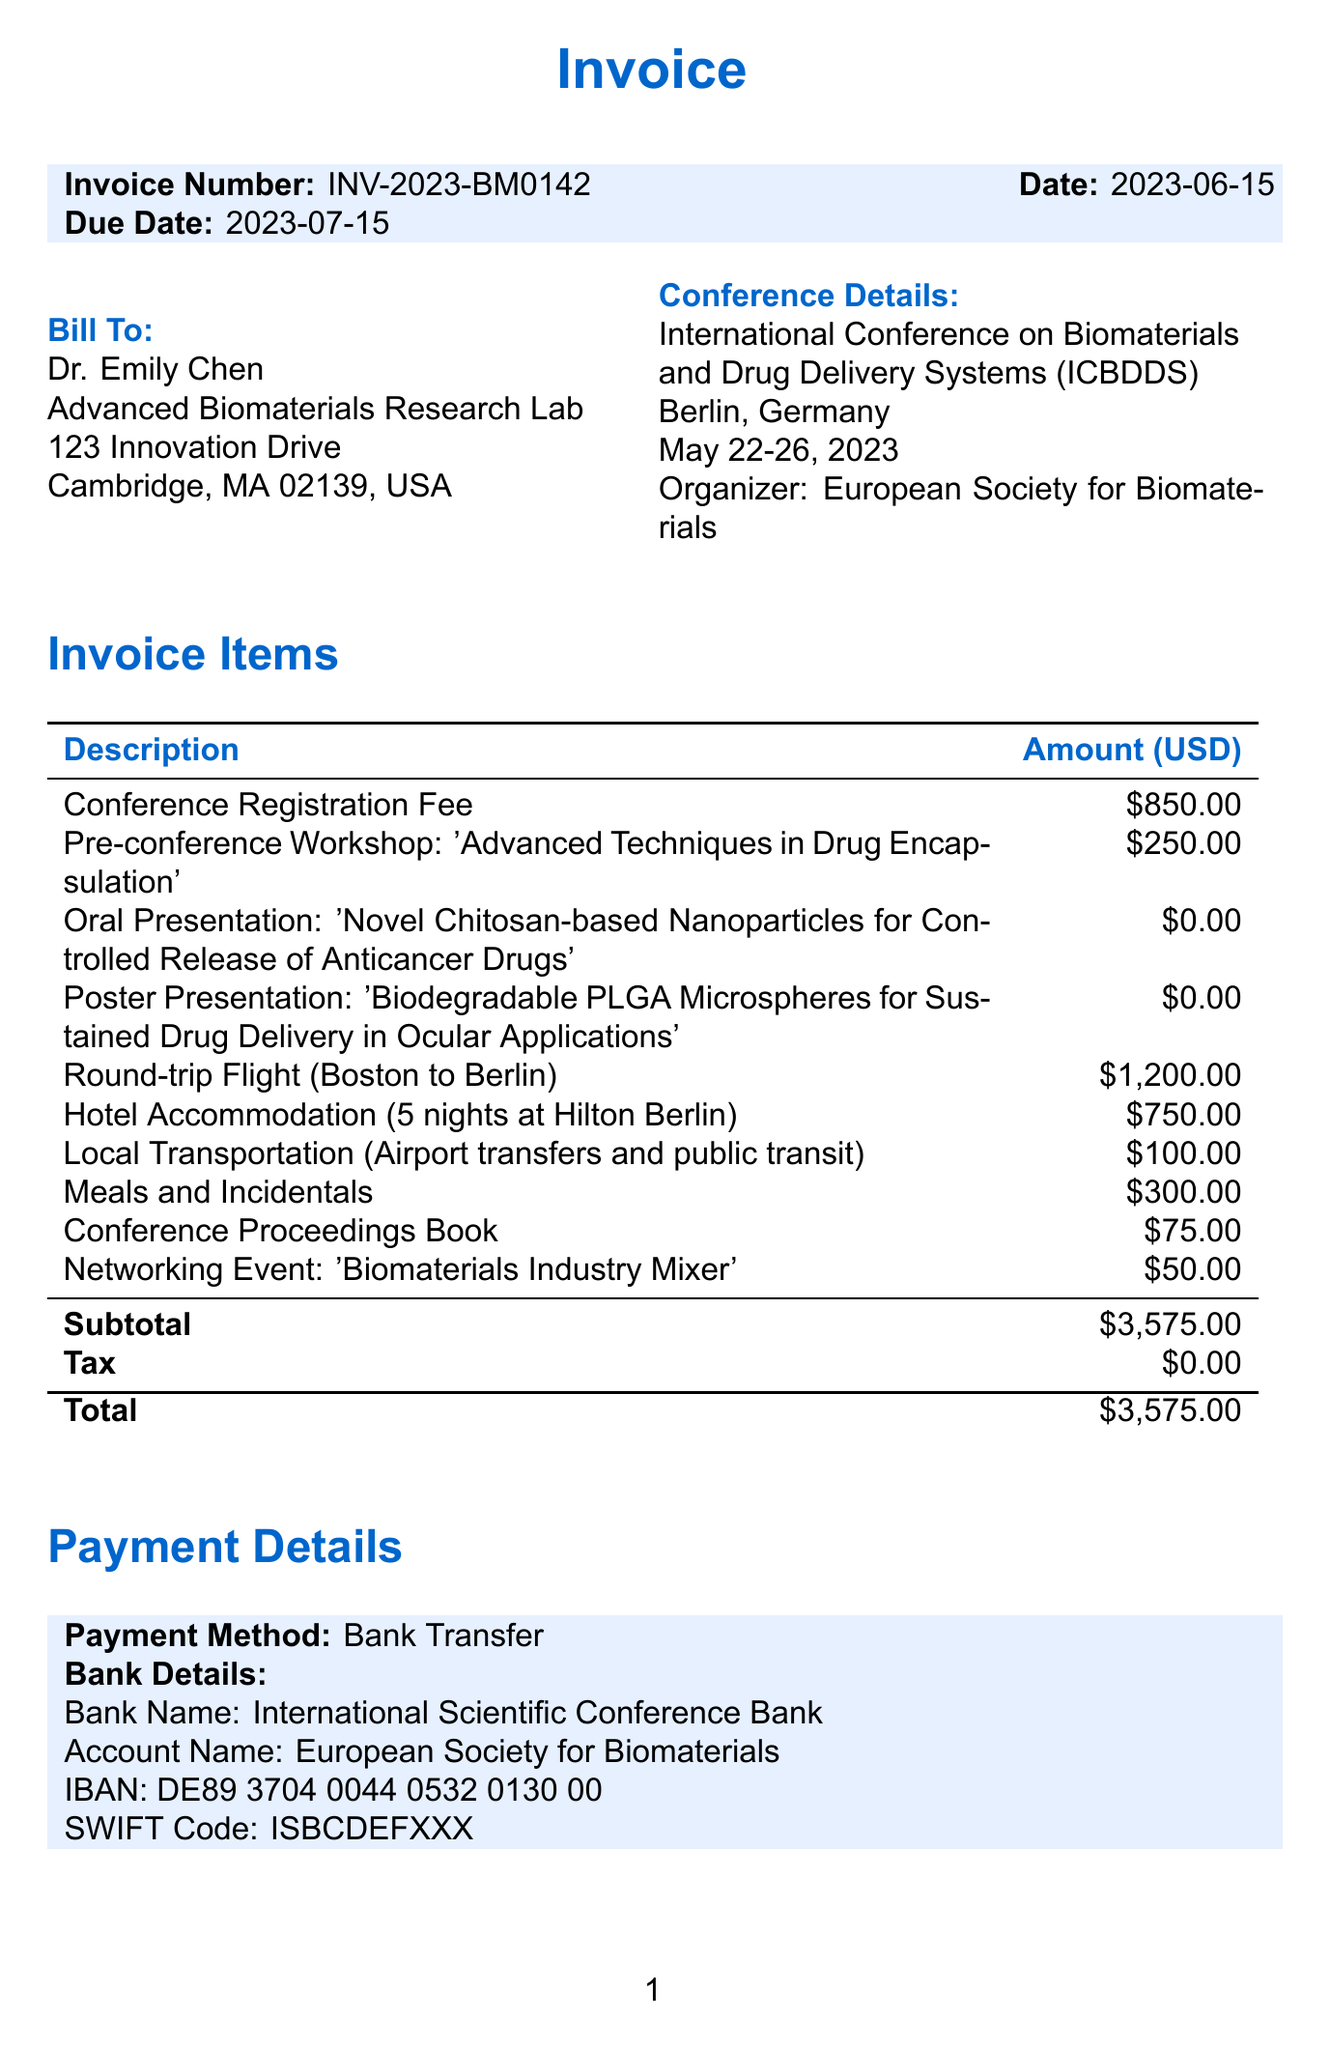What is the invoice number? The invoice number is specified in the invoice details section.
Answer: INV-2023-BM0142 Who is the bill to? The "bill to" section mentions the recipient of the invoice.
Answer: Dr. Emily Chen What is the total amount due? The total amount due is listed in the payment details section.
Answer: $3,575.00 What dates was the conference held? The conference dates are clearly stated under the conference details section.
Answer: May 22-26, 2023 How much was the Conference Registration Fee? The amount for the Conference Registration Fee is itemized in the invoice items.
Answer: $850.00 What were the travel expenses for the round-trip flight? The travel expenses section provides details on individual costs, including the round-trip flight.
Answer: $1,200.00 How much did the hotel accommodation cost? The invoice includes specific amounts for accommodation in the travel expenses.
Answer: $750.00 What payment method is specified in the invoice? The payment details section indicates the method of payment expected.
Answer: Bank Transfer Which organizer hosted the conference? The organizer of the conference is mentioned in the conference details section.
Answer: European Society for Biomaterials 